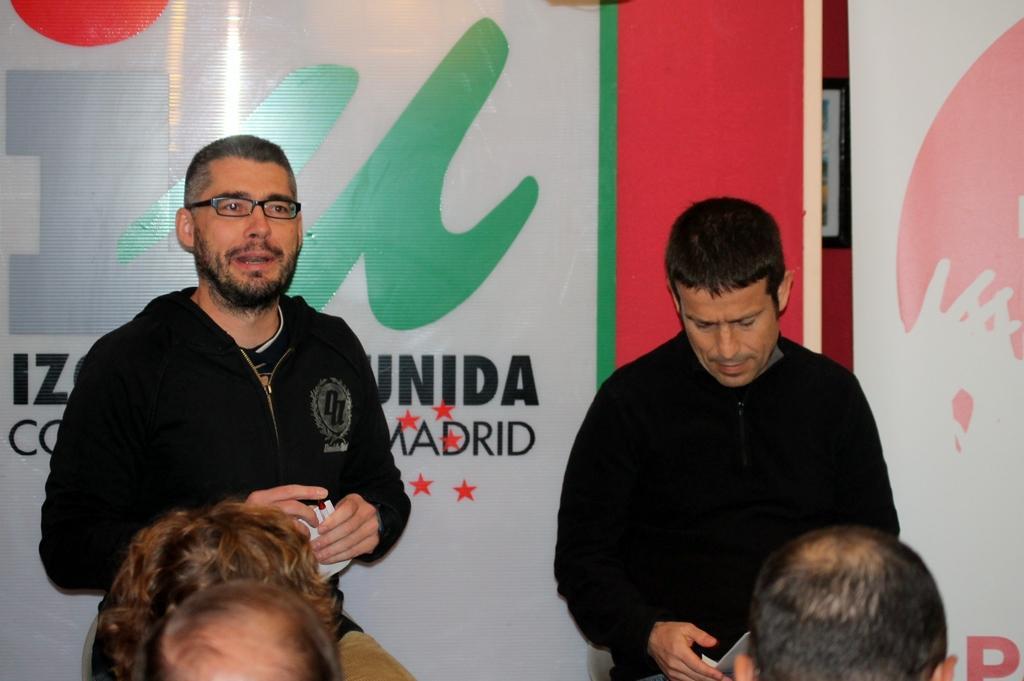In one or two sentences, can you explain what this image depicts? In the picture we can see two men are standing and they are in black jackets and holding something in the hands and in front of them, we can see some people are sitting and behind them we can see a hoarding with an advertisement on it. 